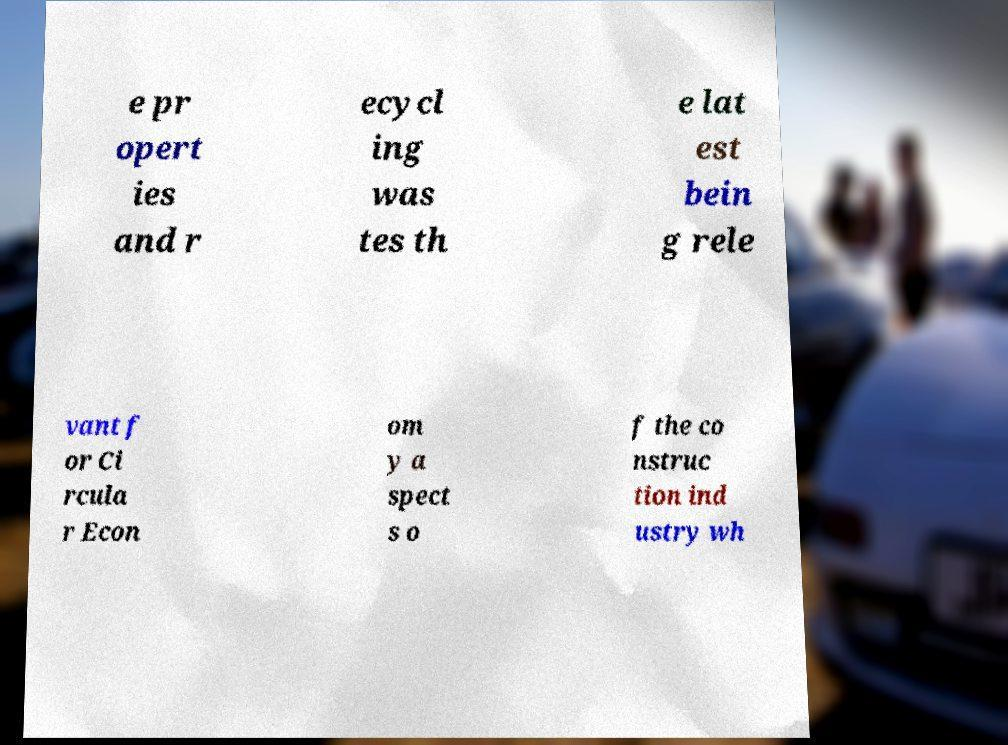Could you assist in decoding the text presented in this image and type it out clearly? e pr opert ies and r ecycl ing was tes th e lat est bein g rele vant f or Ci rcula r Econ om y a spect s o f the co nstruc tion ind ustry wh 